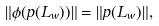Convert formula to latex. <formula><loc_0><loc_0><loc_500><loc_500>\| \phi ( p ( L _ { w } ) ) \| = \| p ( L _ { w } ) \| ,</formula> 